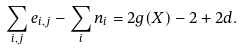<formula> <loc_0><loc_0><loc_500><loc_500>\sum _ { i , j } e _ { i , j } - \sum _ { i } n _ { i } = 2 g ( X ) - 2 + 2 d .</formula> 